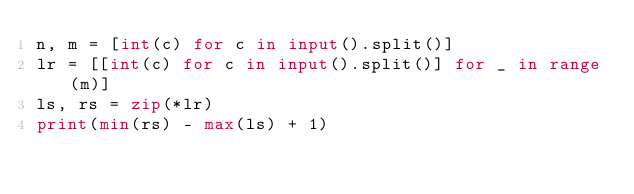Convert code to text. <code><loc_0><loc_0><loc_500><loc_500><_Python_>n, m = [int(c) for c in input().split()]
lr = [[int(c) for c in input().split()] for _ in range(m)]
ls, rs = zip(*lr)
print(min(rs) - max(ls) + 1)</code> 